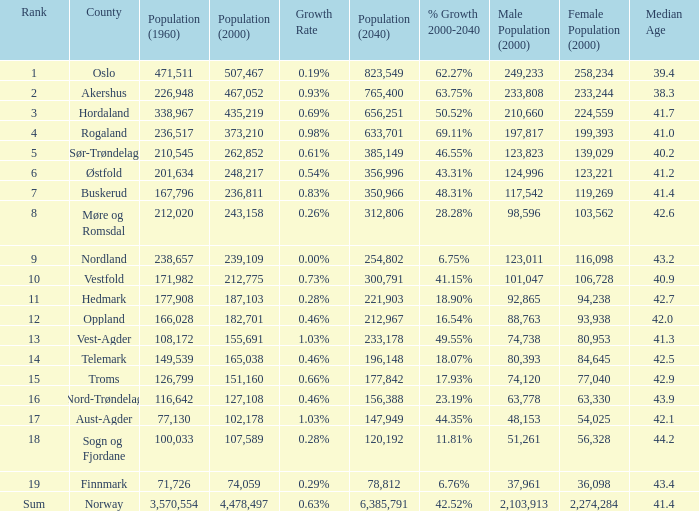What was the population of a county in 2040 that had a population less than 108,172 in 2000 and less than 107,589 in 1960? 2.0. 